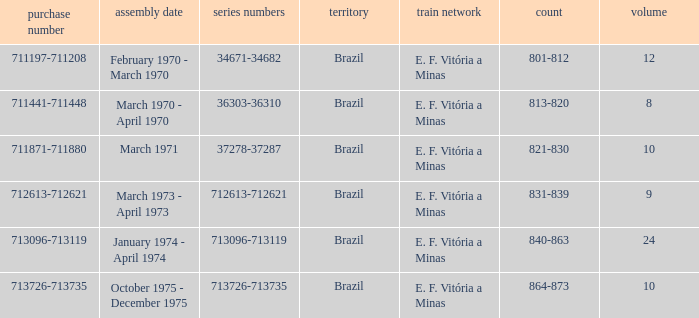How many railroads have the numbers 864-873? 1.0. 